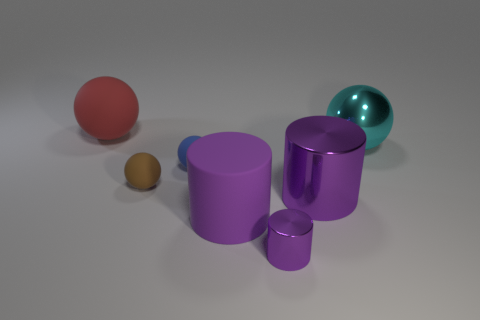What is the material of the tiny blue ball?
Offer a very short reply. Rubber. There is a large rubber object that is right of the large red thing; what is its color?
Give a very brief answer. Purple. How many rubber things have the same color as the big rubber sphere?
Your answer should be compact. 0. What number of matte objects are behind the metallic ball and in front of the large metallic cylinder?
Offer a very short reply. 0. There is another metallic object that is the same size as the brown thing; what shape is it?
Your answer should be compact. Cylinder. How big is the cyan metallic thing?
Your response must be concise. Large. What material is the large ball that is to the right of the big ball that is on the left side of the shiny thing that is in front of the large rubber cylinder?
Your answer should be very brief. Metal. There is a cylinder that is made of the same material as the red sphere; what is its color?
Keep it short and to the point. Purple. What number of metal objects are in front of the purple cylinder that is right of the tiny object in front of the brown sphere?
Offer a terse response. 1. There is a tiny cylinder that is the same color as the big shiny cylinder; what material is it?
Your answer should be compact. Metal. 